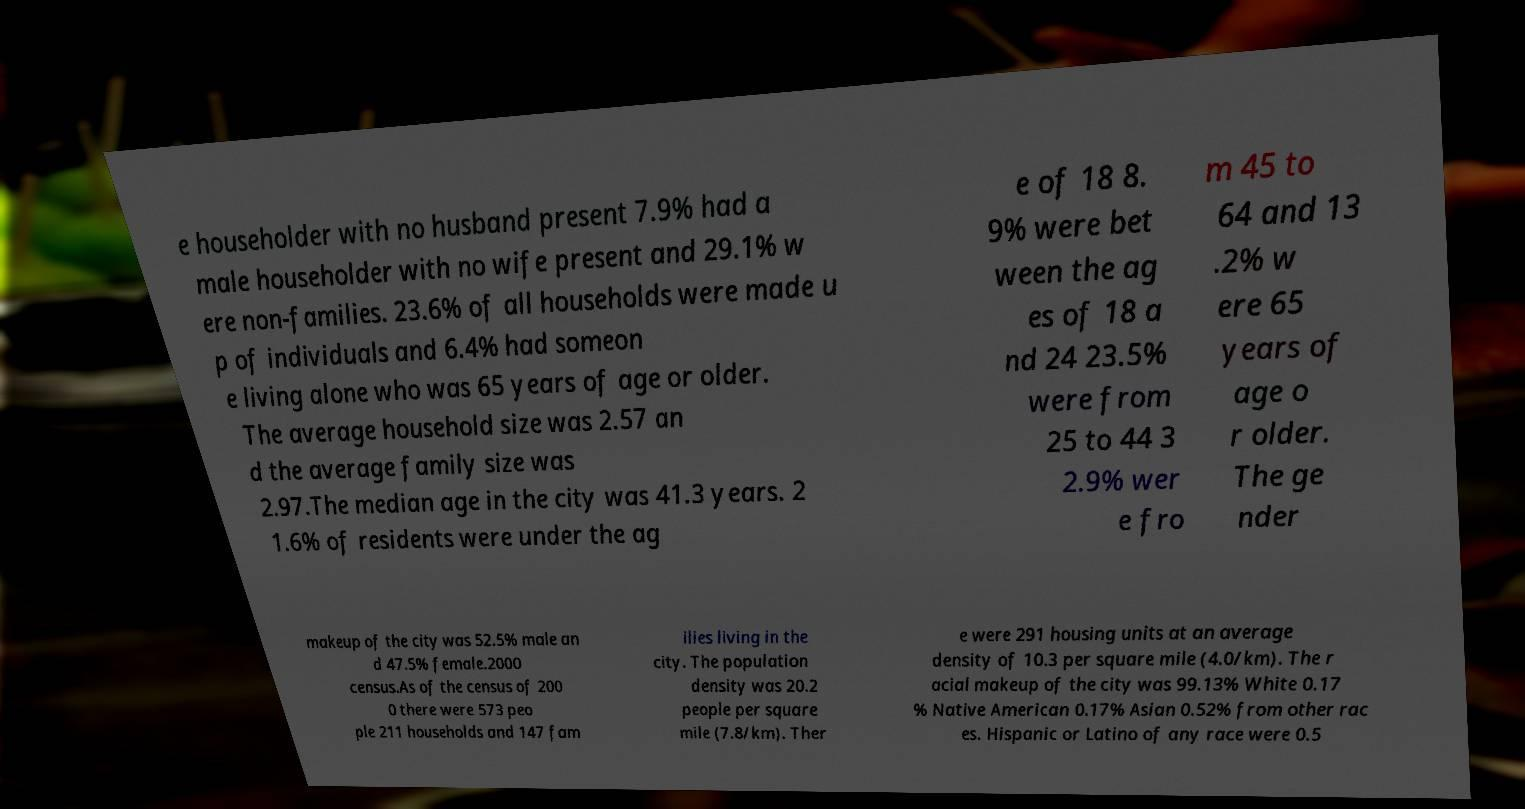Can you accurately transcribe the text from the provided image for me? e householder with no husband present 7.9% had a male householder with no wife present and 29.1% w ere non-families. 23.6% of all households were made u p of individuals and 6.4% had someon e living alone who was 65 years of age or older. The average household size was 2.57 an d the average family size was 2.97.The median age in the city was 41.3 years. 2 1.6% of residents were under the ag e of 18 8. 9% were bet ween the ag es of 18 a nd 24 23.5% were from 25 to 44 3 2.9% wer e fro m 45 to 64 and 13 .2% w ere 65 years of age o r older. The ge nder makeup of the city was 52.5% male an d 47.5% female.2000 census.As of the census of 200 0 there were 573 peo ple 211 households and 147 fam ilies living in the city. The population density was 20.2 people per square mile (7.8/km). Ther e were 291 housing units at an average density of 10.3 per square mile (4.0/km). The r acial makeup of the city was 99.13% White 0.17 % Native American 0.17% Asian 0.52% from other rac es. Hispanic or Latino of any race were 0.5 